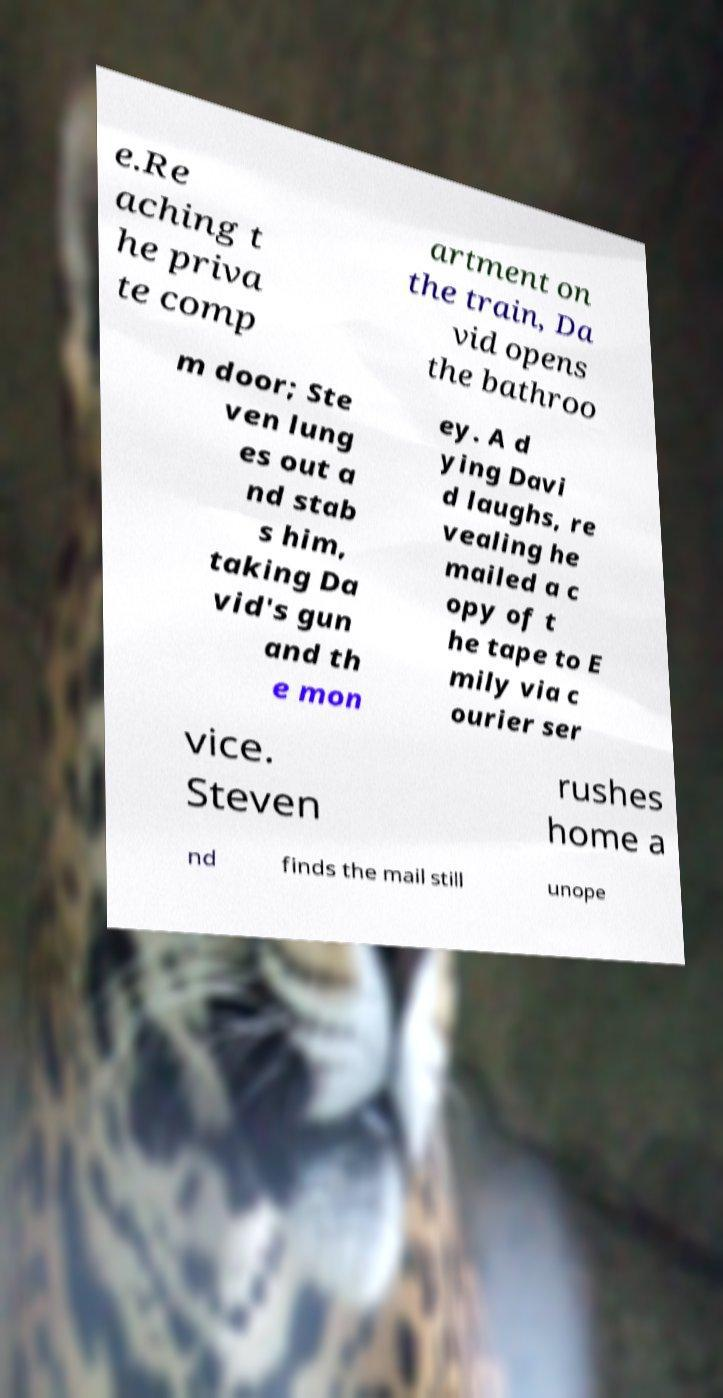Could you extract and type out the text from this image? e.Re aching t he priva te comp artment on the train, Da vid opens the bathroo m door; Ste ven lung es out a nd stab s him, taking Da vid's gun and th e mon ey. A d ying Davi d laughs, re vealing he mailed a c opy of t he tape to E mily via c ourier ser vice. Steven rushes home a nd finds the mail still unope 